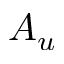<formula> <loc_0><loc_0><loc_500><loc_500>A _ { u }</formula> 